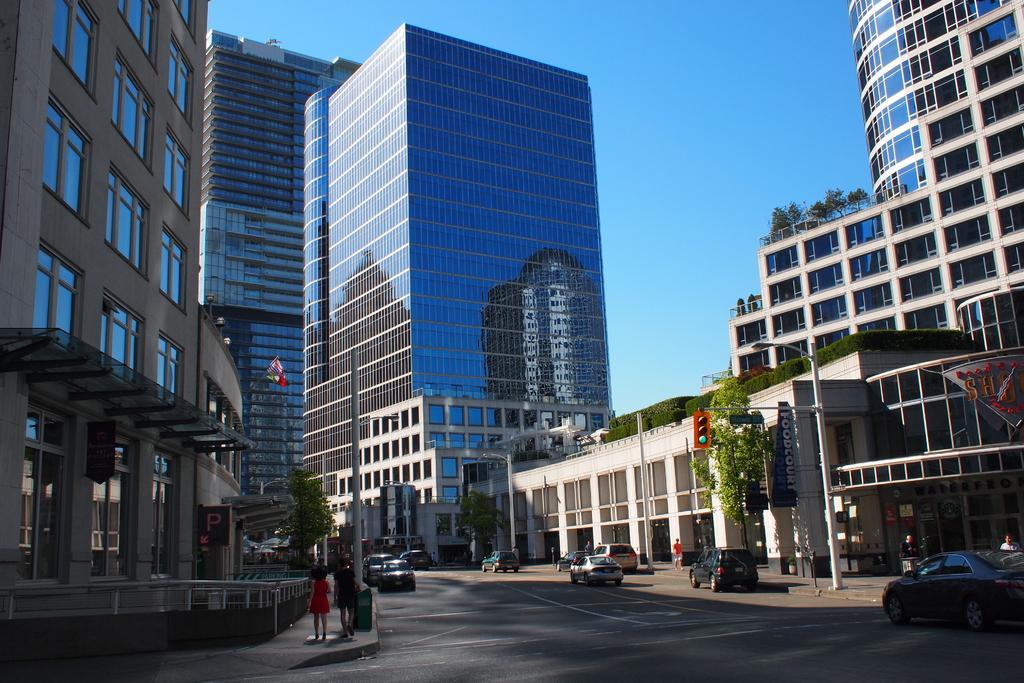Could you give a brief overview of what you see in this image? Here in this picture we can see buildings present all over there and in the middle we can see cars present on the road here and there and we can see plants and trees present here and there and we can also see light posts and flag posts, sign boards and hoardings present here and there. 